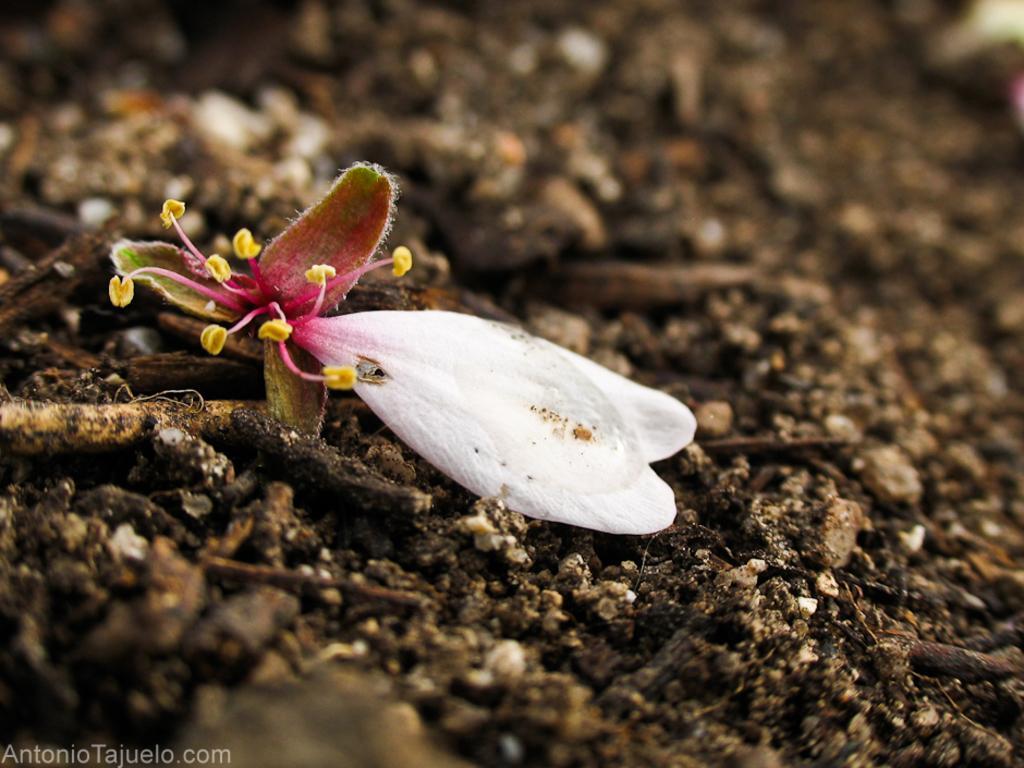Could you give a brief overview of what you see in this image? On the left side, there is a flower having white color petal, pink color styles and yellow color anthers on the ground, on which there are sticks and stones. And the background is blurred. 